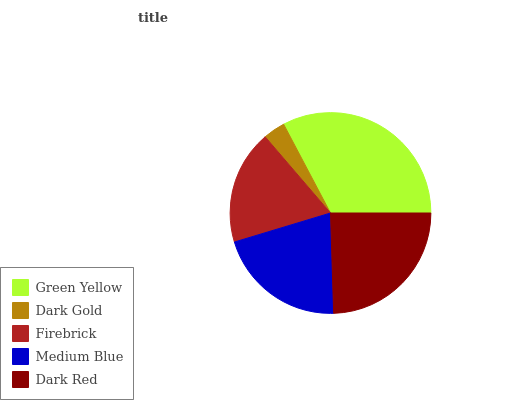Is Dark Gold the minimum?
Answer yes or no. Yes. Is Green Yellow the maximum?
Answer yes or no. Yes. Is Firebrick the minimum?
Answer yes or no. No. Is Firebrick the maximum?
Answer yes or no. No. Is Firebrick greater than Dark Gold?
Answer yes or no. Yes. Is Dark Gold less than Firebrick?
Answer yes or no. Yes. Is Dark Gold greater than Firebrick?
Answer yes or no. No. Is Firebrick less than Dark Gold?
Answer yes or no. No. Is Medium Blue the high median?
Answer yes or no. Yes. Is Medium Blue the low median?
Answer yes or no. Yes. Is Green Yellow the high median?
Answer yes or no. No. Is Green Yellow the low median?
Answer yes or no. No. 